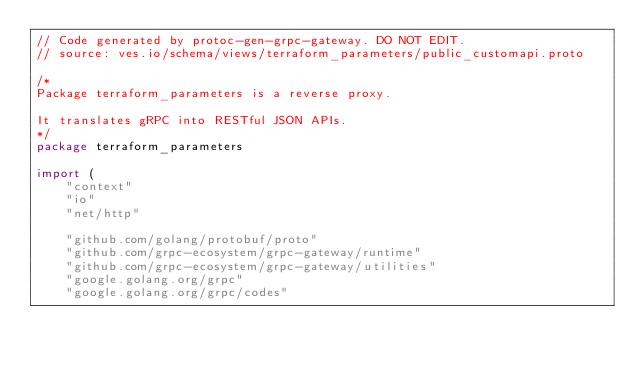Convert code to text. <code><loc_0><loc_0><loc_500><loc_500><_Go_>// Code generated by protoc-gen-grpc-gateway. DO NOT EDIT.
// source: ves.io/schema/views/terraform_parameters/public_customapi.proto

/*
Package terraform_parameters is a reverse proxy.

It translates gRPC into RESTful JSON APIs.
*/
package terraform_parameters

import (
	"context"
	"io"
	"net/http"

	"github.com/golang/protobuf/proto"
	"github.com/grpc-ecosystem/grpc-gateway/runtime"
	"github.com/grpc-ecosystem/grpc-gateway/utilities"
	"google.golang.org/grpc"
	"google.golang.org/grpc/codes"</code> 